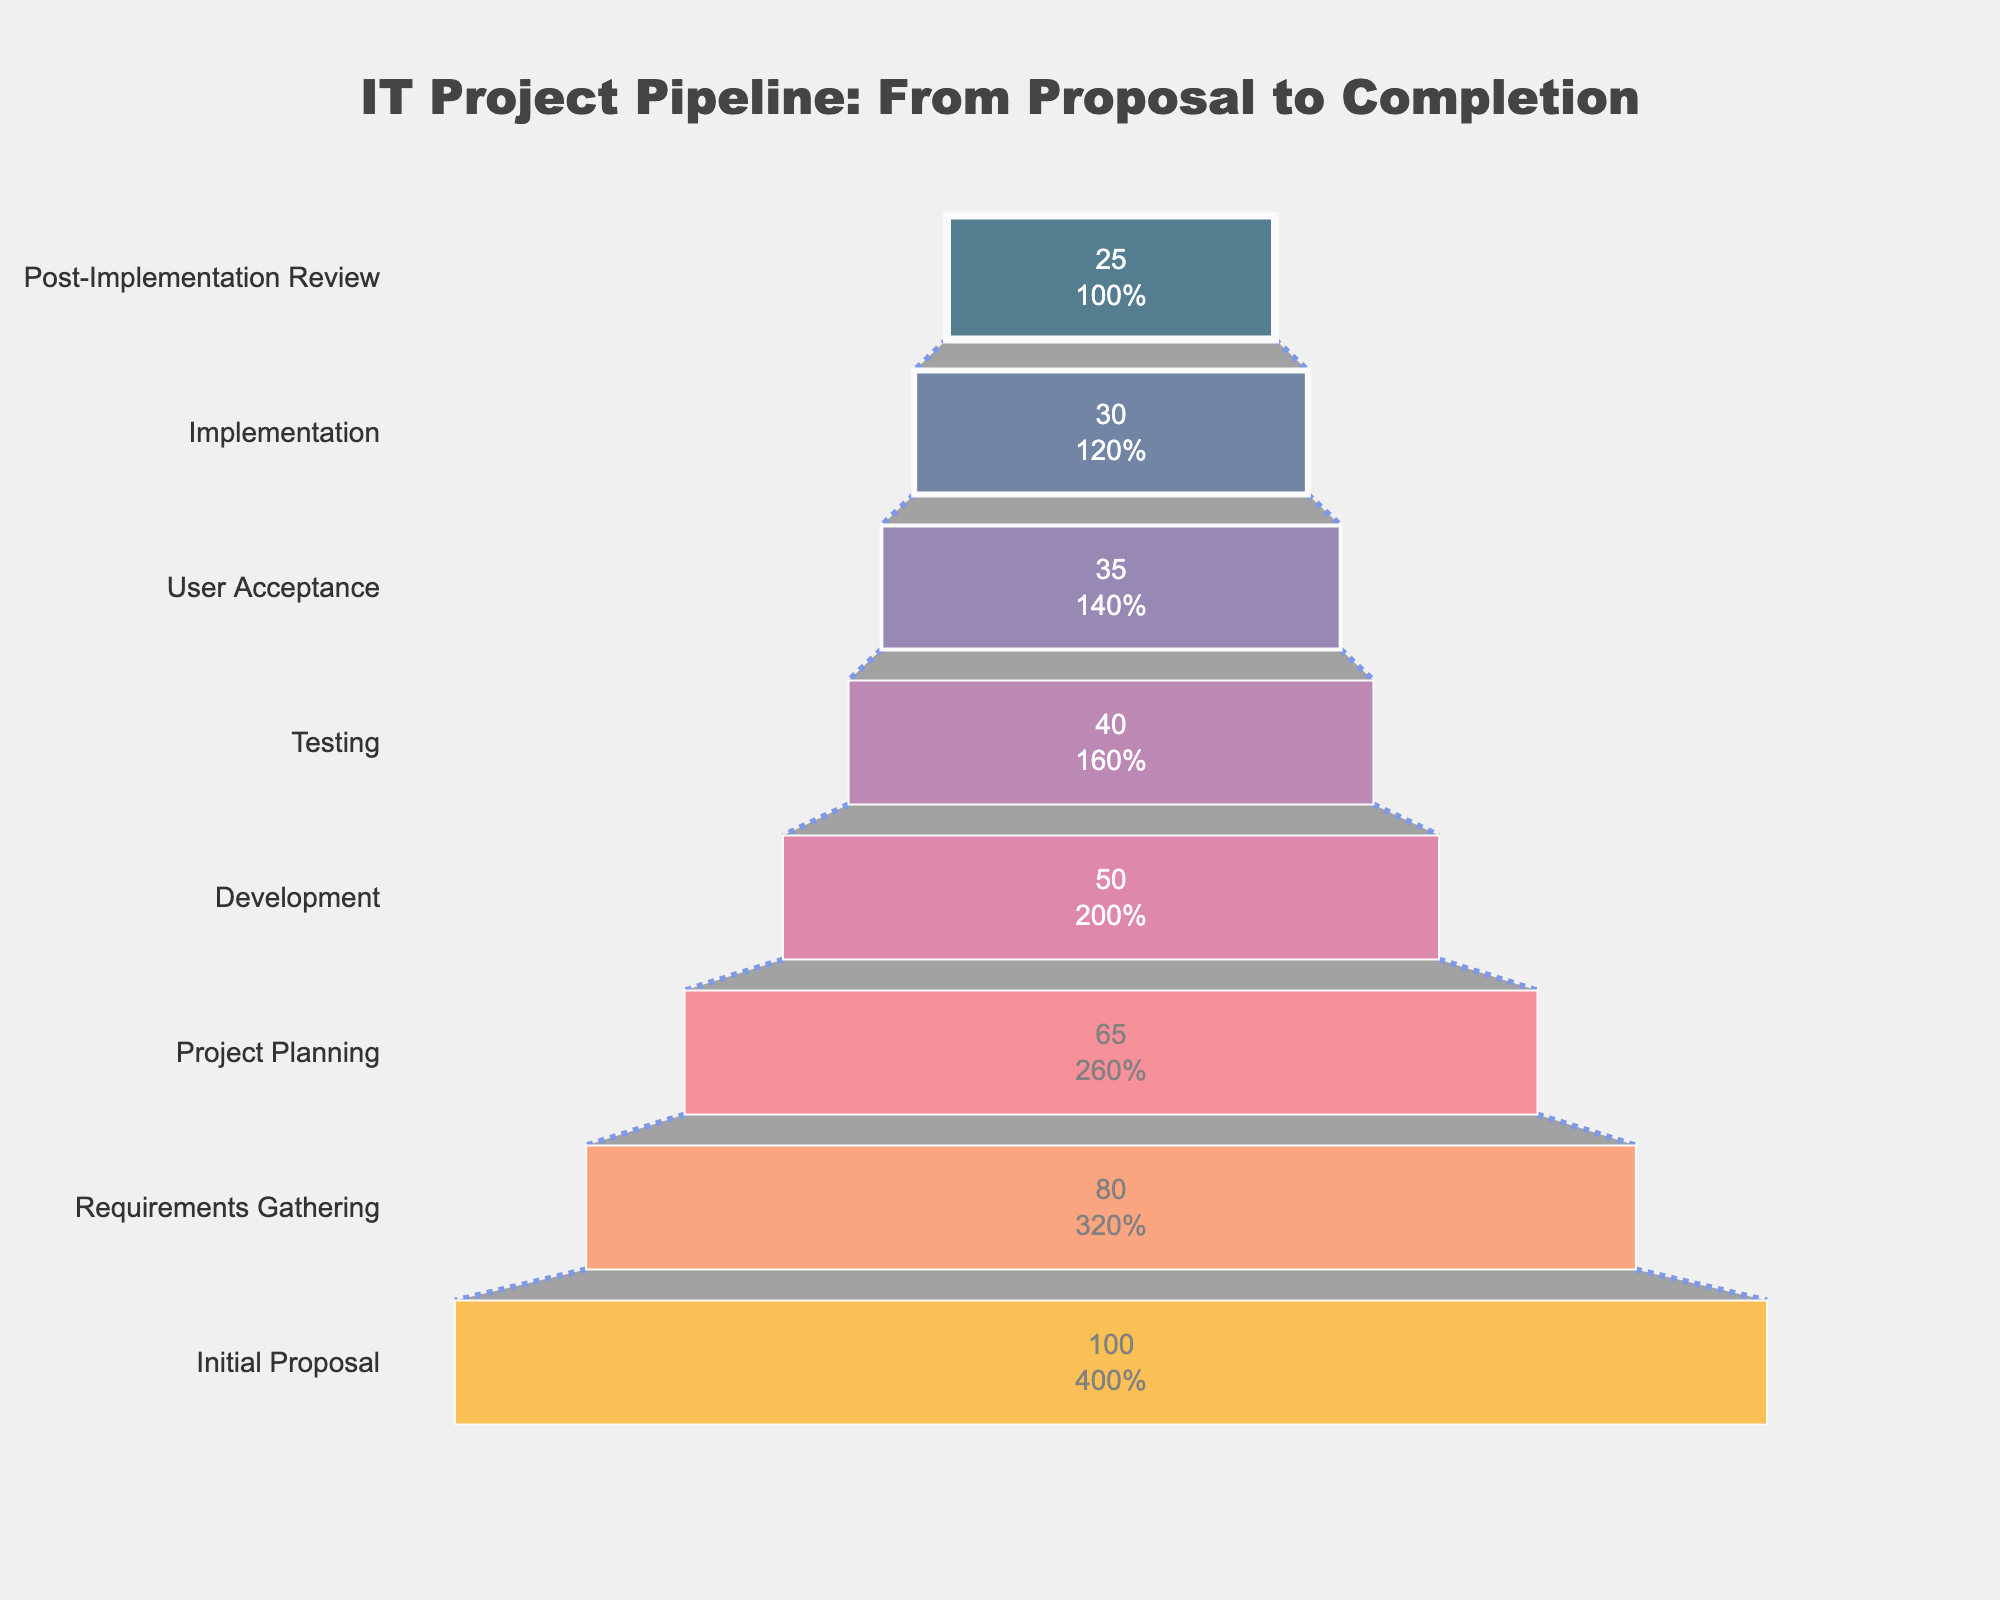What is the title of the funnel chart? The title is directly visible at the top part of the funnel chart. It is labeled as "IT Project Pipeline: From Proposal to Completion".
Answer: IT Project Pipeline: From Proposal to Completion How many projects were initially proposed? The number of initially proposed projects is written within the first section of the funnel and is 100.
Answer: 100 At which stage does the largest percentage drop occur? By examining the transitions between stages, the largest drop in percentage occurs between 'Initial Proposal' (100) and 'Requirements Gathering' (80). The drop here is 20%.
Answer: Between Initial Proposal and Requirements Gathering Which stages have 50 or fewer projects remaining? Look at each stage's number of projects. The stages with 50 or fewer projects remaining are 'Development', 'Testing', 'User Acceptance', 'Implementation', and 'Post-Implementation Review'.
Answer: Development, Testing, User Acceptance, Implementation, Post-Implementation Review What percentage of projects reach the User Acceptance stage? The percentage is visible inside the 'User Acceptance' section of the funnel chart, which is 35%.
Answer: 35% What is the difference in the number of projects between the Development stage and the Implementation stage? The Development stage has 50 projects, and the Implementation stage has 30 projects. The difference is 50 - 30 = 20 projects.
Answer: 20 projects How many stages are depicted in the funnel chart? Count the number of stages listed along the y-axis. There are eight different stages.
Answer: 8 Which stage directly follows the Testing stage? Look at the sequence of stages along the y-axis; the stage that directly follows 'Testing' is 'User Acceptance'.
Answer: User Acceptance What percentage of projects advance past the Project Planning stage? The projects advancing past 'Project Planning' stage are counted starting from the 'Development' stage and onwards. The percentage for 'Development' is 50%.
Answer: 50% Which stage has the smallest line width in the funnel chart? By examining the line widths marked on each stage, several stages have the smallest width, which are 'Testing', 'User Acceptance', 'Implementation', and 'Post-Implementation Review'.
Answer: Testing, User Acceptance, Implementation, Post-Implementation Review 